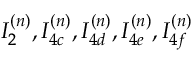Convert formula to latex. <formula><loc_0><loc_0><loc_500><loc_500>I _ { 2 } ^ { ( n ) } , I _ { 4 c } ^ { ( n ) } , I _ { 4 d } ^ { ( n ) } , I _ { 4 e } ^ { ( n ) } , I _ { 4 f } ^ { ( n ) }</formula> 